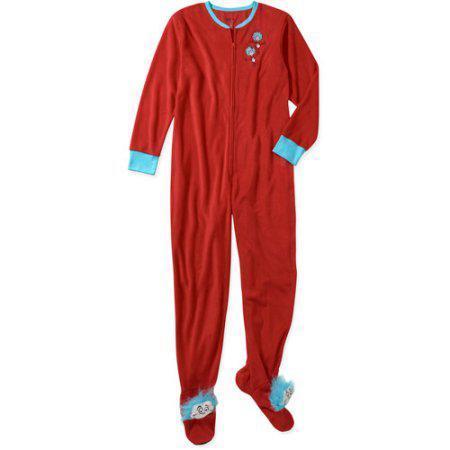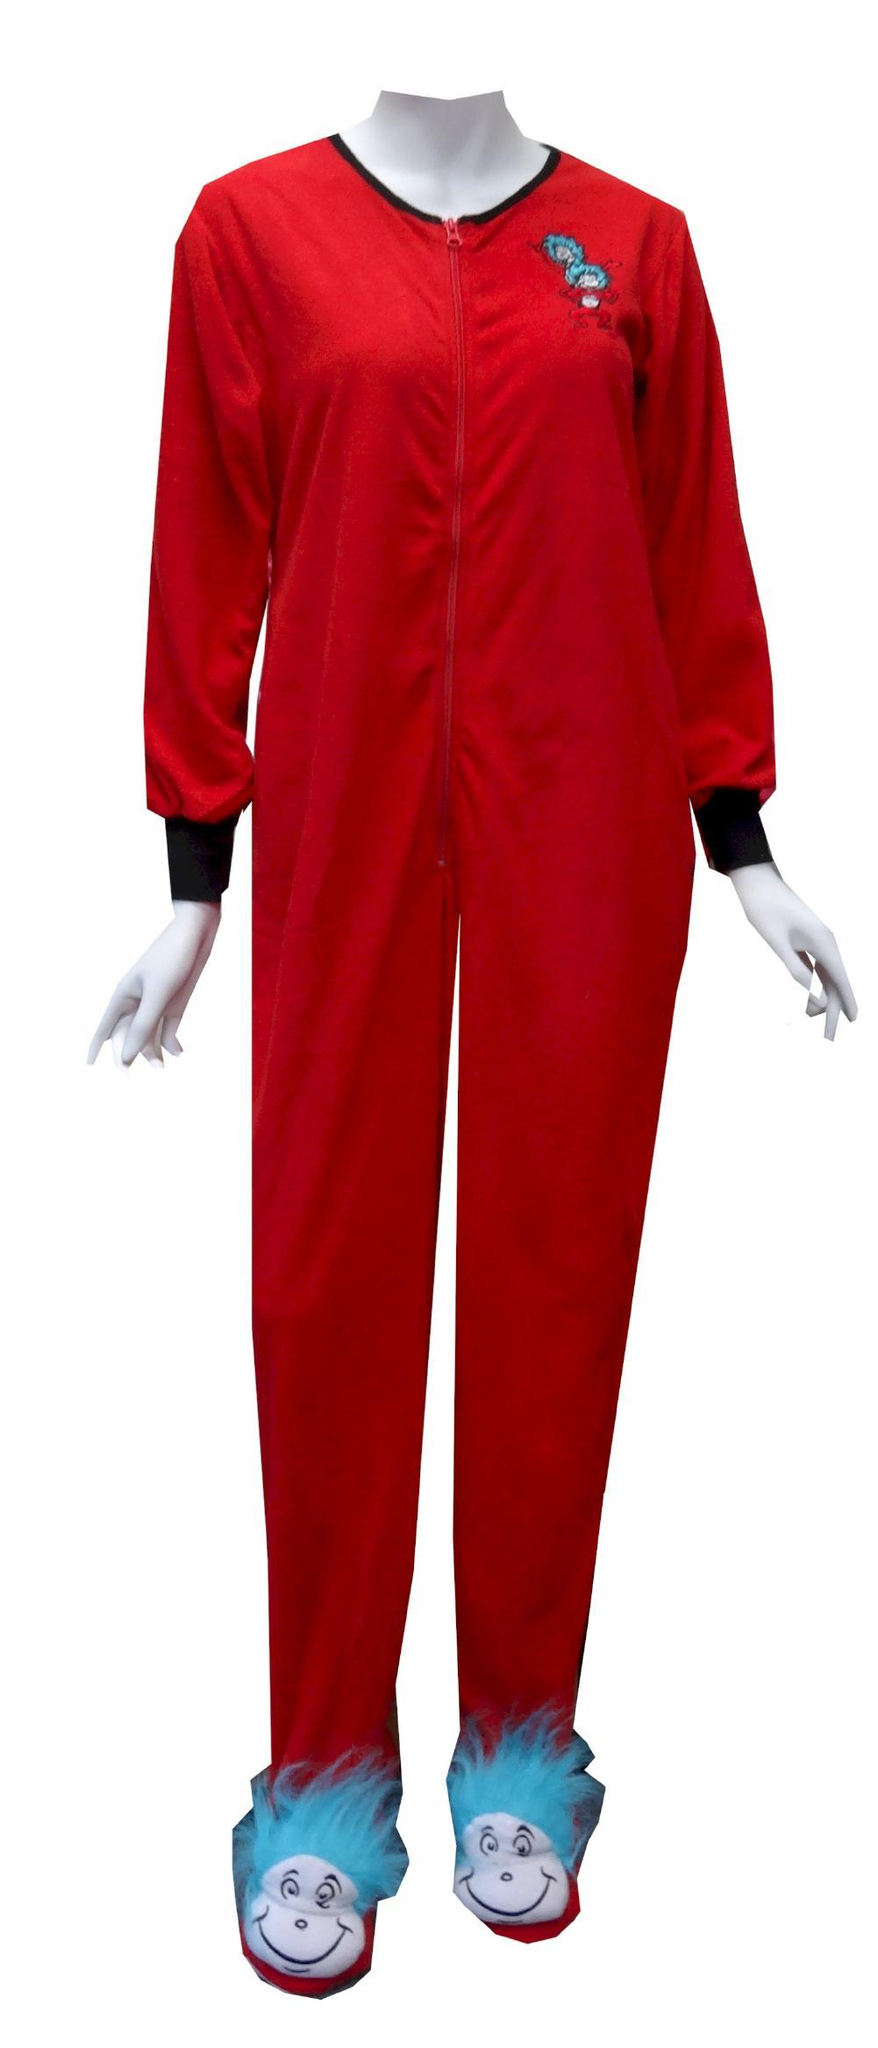The first image is the image on the left, the second image is the image on the right. Evaluate the accuracy of this statement regarding the images: "At least one image shows red onesie pajamas". Is it true? Answer yes or no. Yes. The first image is the image on the left, the second image is the image on the right. Analyze the images presented: Is the assertion "One or more outfits are """"Thing 1 and Thing 2"""" themed." valid? Answer yes or no. Yes. 